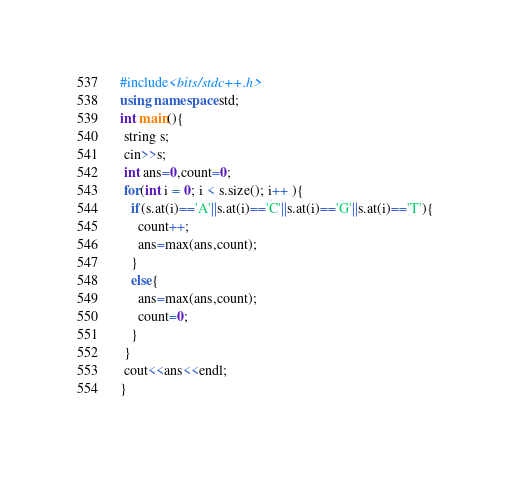Convert code to text. <code><loc_0><loc_0><loc_500><loc_500><_C++_>#include<bits/stdc++.h>
using namespace std;
int main(){
 string s;
 cin>>s;
 int ans=0,count=0;
 for(int i = 0; i < s.size(); i++ ){
   if(s.at(i)=='A'||s.at(i)=='C'||s.at(i)=='G'||s.at(i)=='T'){
     count++;
     ans=max(ans,count);
   }
   else{
     ans=max(ans,count);
     count=0;
   } 
 } 
 cout<<ans<<endl;
}</code> 